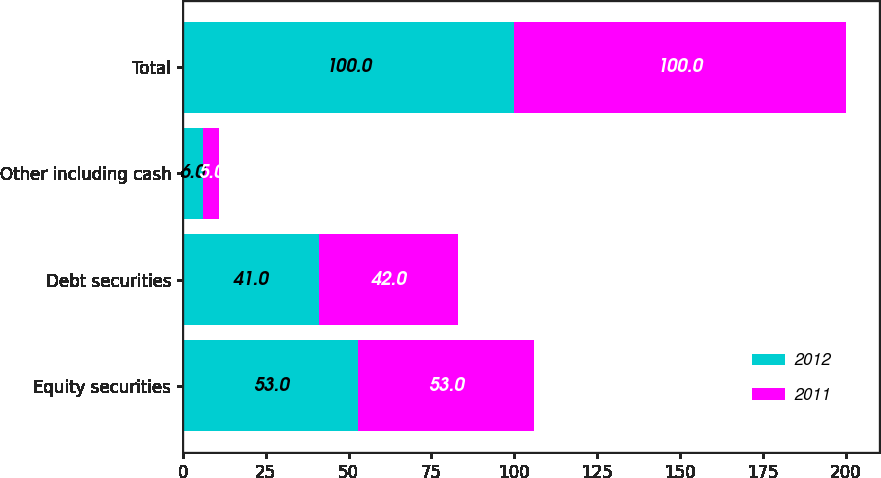<chart> <loc_0><loc_0><loc_500><loc_500><stacked_bar_chart><ecel><fcel>Equity securities<fcel>Debt securities<fcel>Other including cash<fcel>Total<nl><fcel>2012<fcel>53<fcel>41<fcel>6<fcel>100<nl><fcel>2011<fcel>53<fcel>42<fcel>5<fcel>100<nl></chart> 